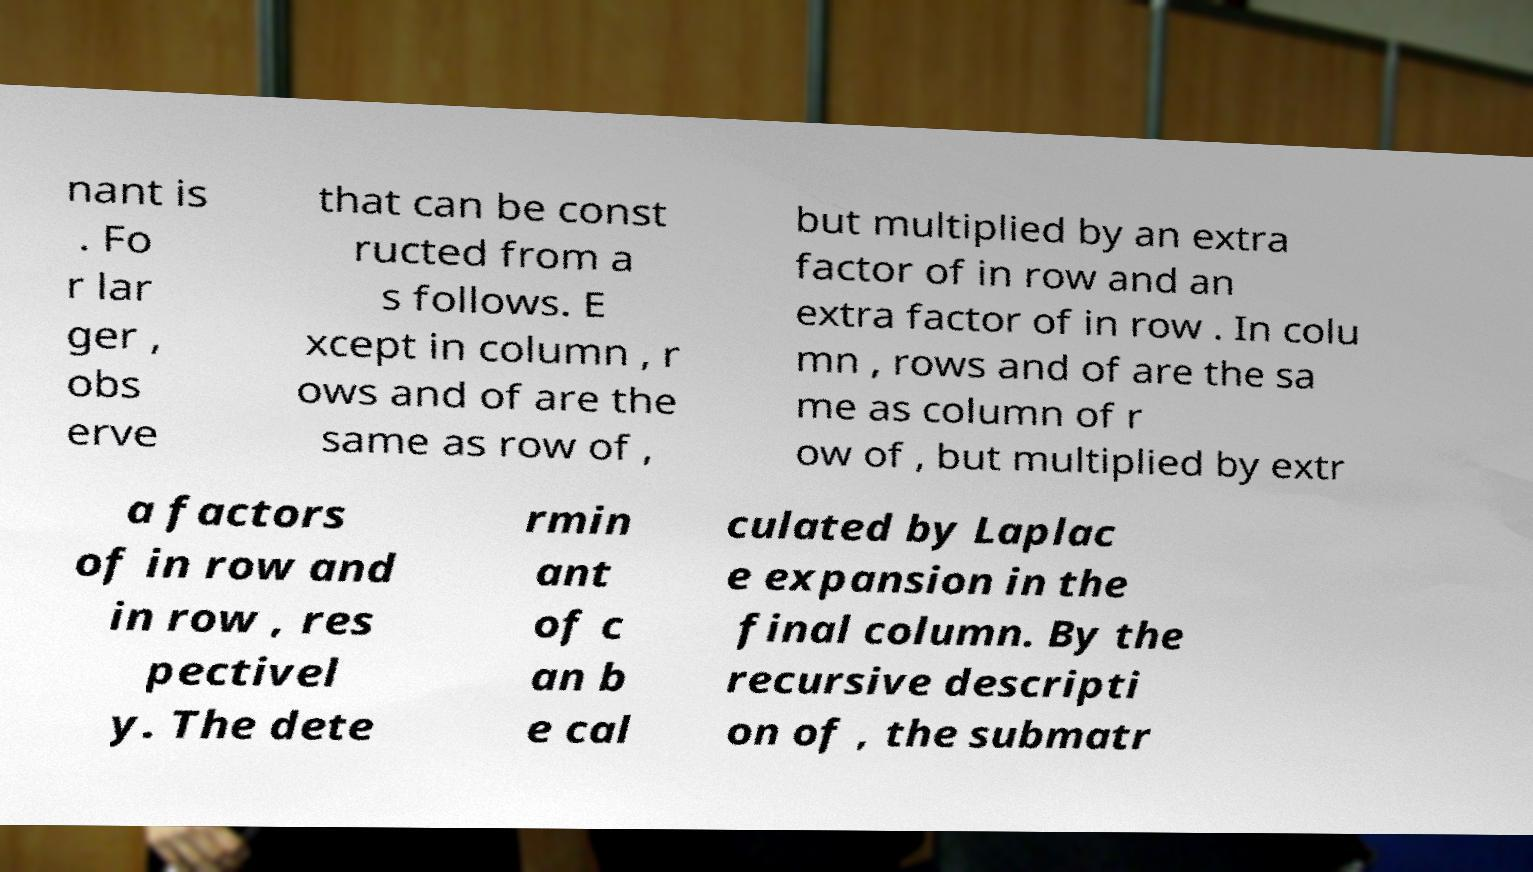Please identify and transcribe the text found in this image. nant is . Fo r lar ger , obs erve that can be const ructed from a s follows. E xcept in column , r ows and of are the same as row of , but multiplied by an extra factor of in row and an extra factor of in row . In colu mn , rows and of are the sa me as column of r ow of , but multiplied by extr a factors of in row and in row , res pectivel y. The dete rmin ant of c an b e cal culated by Laplac e expansion in the final column. By the recursive descripti on of , the submatr 